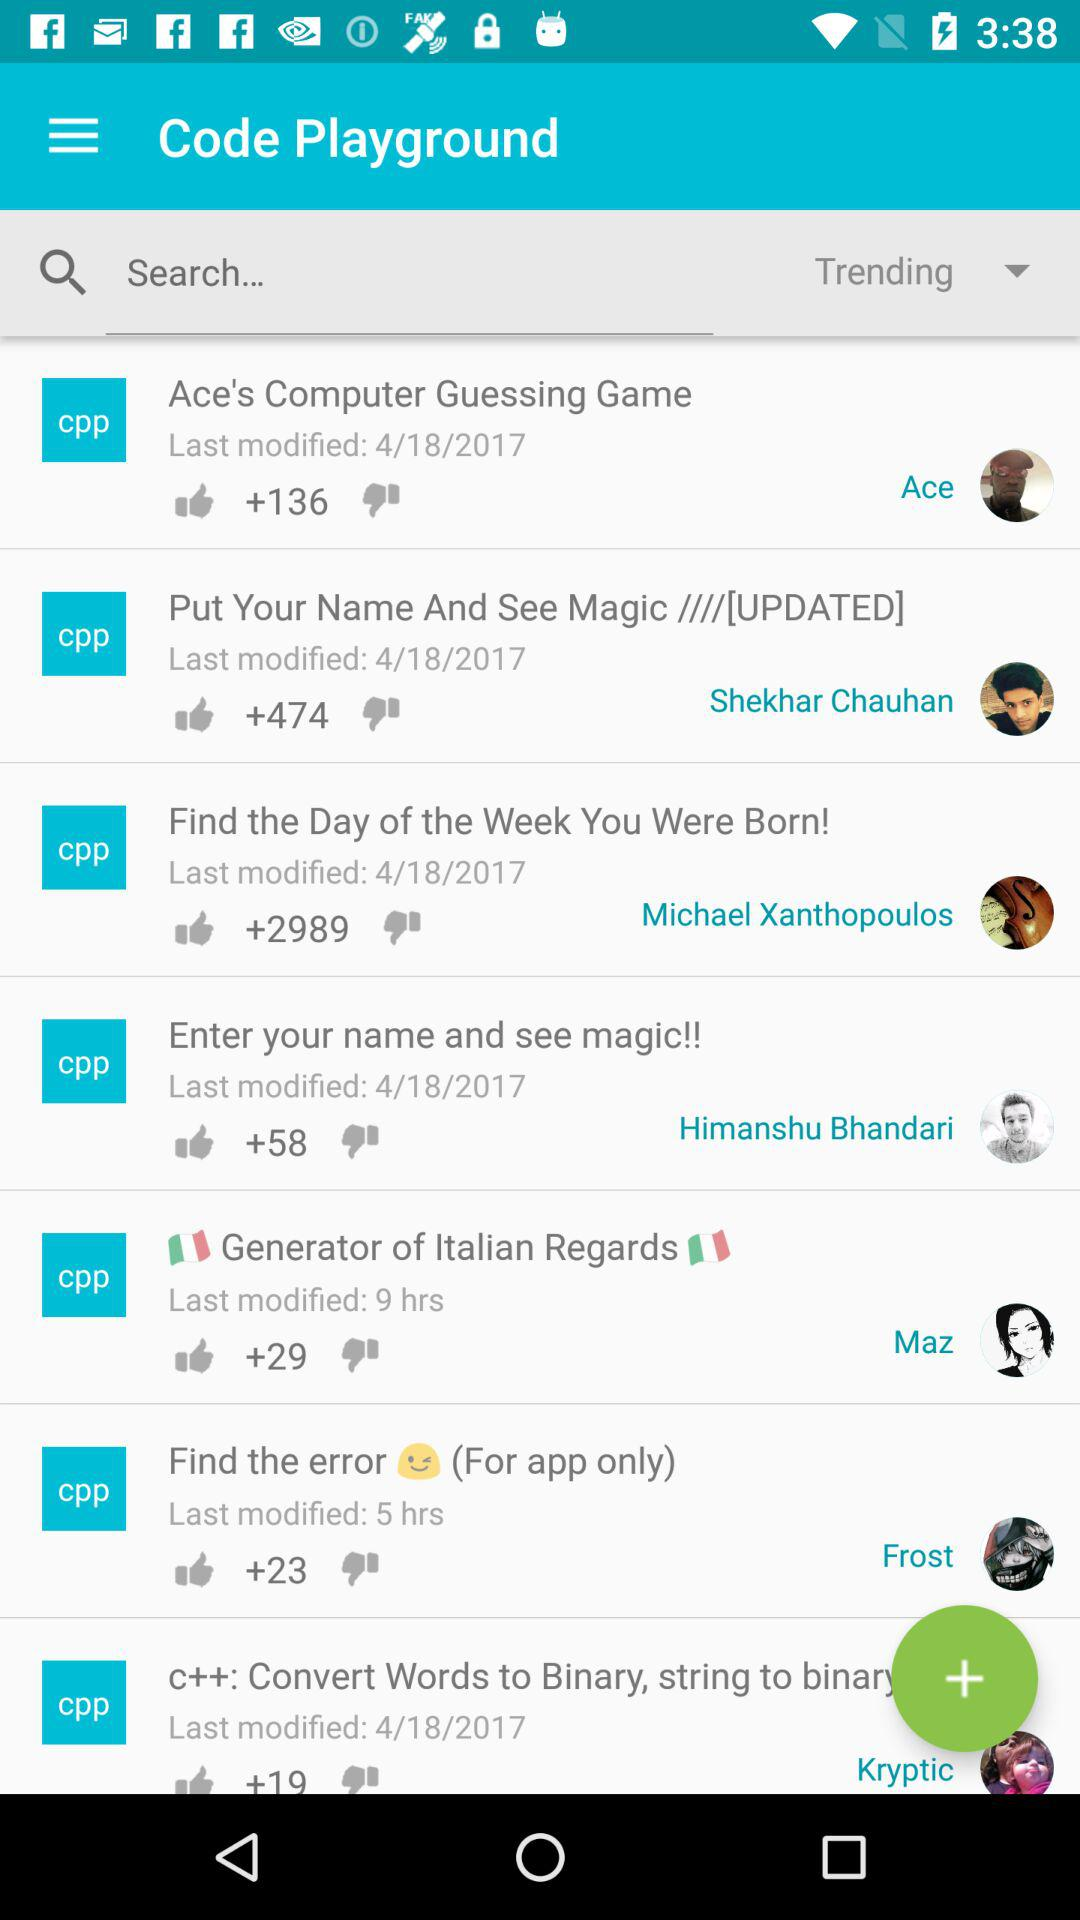How many thumbs up does the item with the most thumbs up have? The item with the most thumbs up in the image has 2,989 likes, an impressive count that suggests it's quite popular among the users of this platform. 